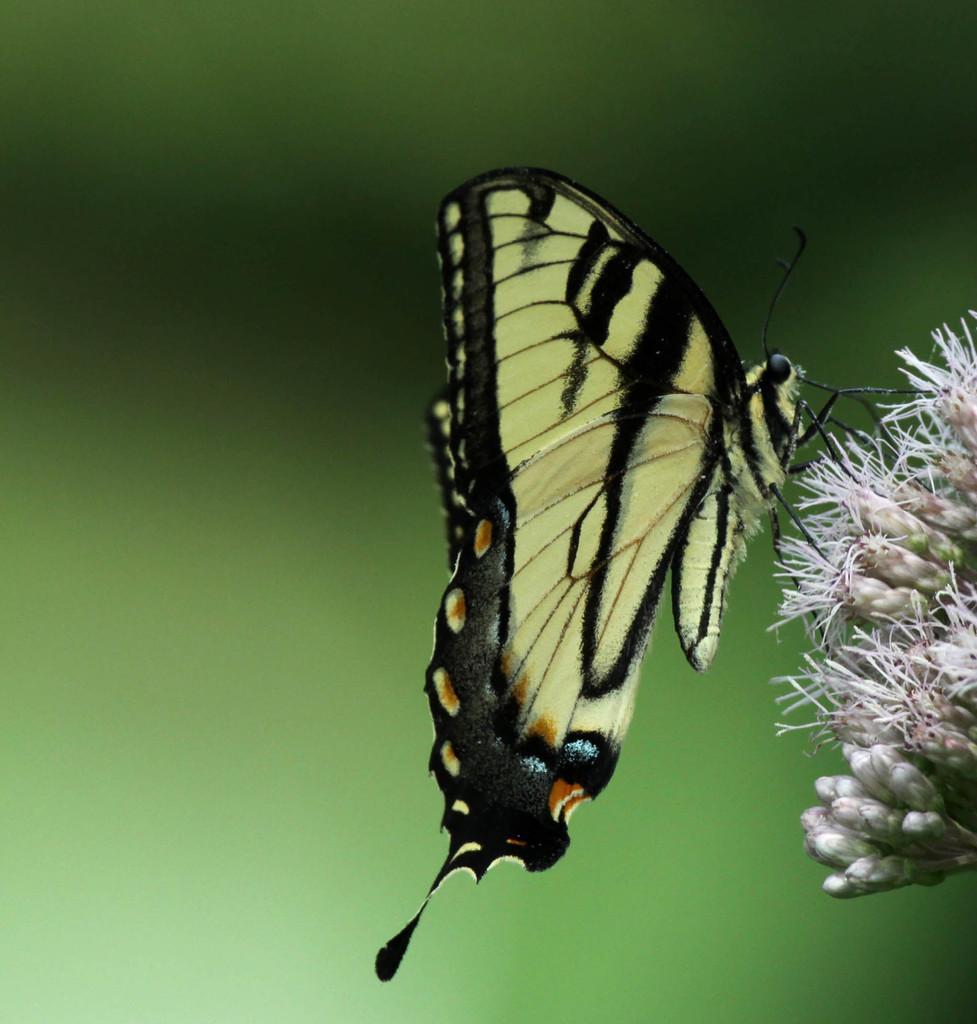In one or two sentences, can you explain what this image depicts? In this image there is a butterfly on flower, in the background it is blurred. 